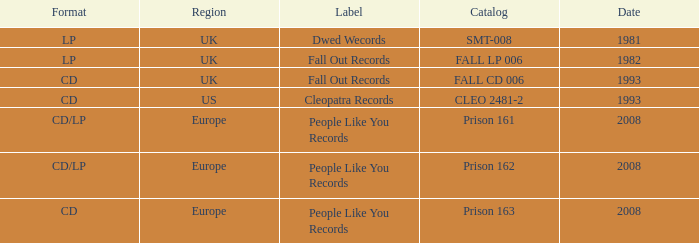Which Label has a Date smaller than 2008, and a Catalog of fall cd 006? Fall Out Records. 